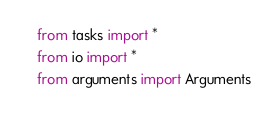<code> <loc_0><loc_0><loc_500><loc_500><_Python_>from tasks import *
from io import *
from arguments import Arguments
</code> 